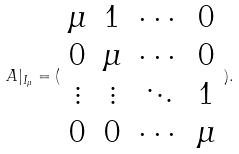<formula> <loc_0><loc_0><loc_500><loc_500>A | _ { I _ { \mu } } = ( \begin{array} { c c c c } \mu & 1 & \cdots & 0 \\ 0 & \mu & \cdots & 0 \\ \vdots & \vdots & \ddots & 1 \\ 0 & 0 & \cdots & \mu \end{array} ) .</formula> 